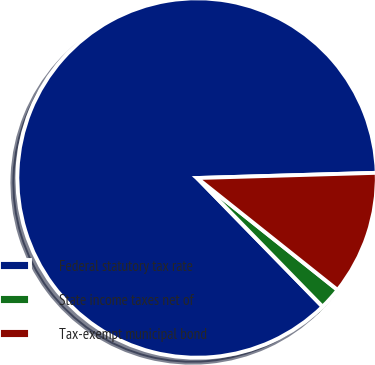Convert chart to OTSL. <chart><loc_0><loc_0><loc_500><loc_500><pie_chart><fcel>Federal statutory tax rate<fcel>State income taxes net of<fcel>Tax-exempt municipal bond<nl><fcel>86.85%<fcel>1.99%<fcel>11.17%<nl></chart> 